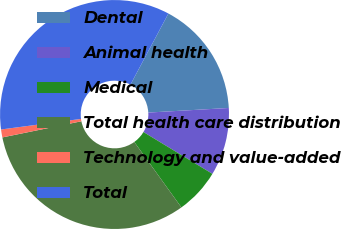Convert chart to OTSL. <chart><loc_0><loc_0><loc_500><loc_500><pie_chart><fcel>Dental<fcel>Animal health<fcel>Medical<fcel>Total health care distribution<fcel>Technology and value-added<fcel>Total<nl><fcel>16.29%<fcel>9.58%<fcel>6.4%<fcel>31.72%<fcel>1.12%<fcel>34.89%<nl></chart> 